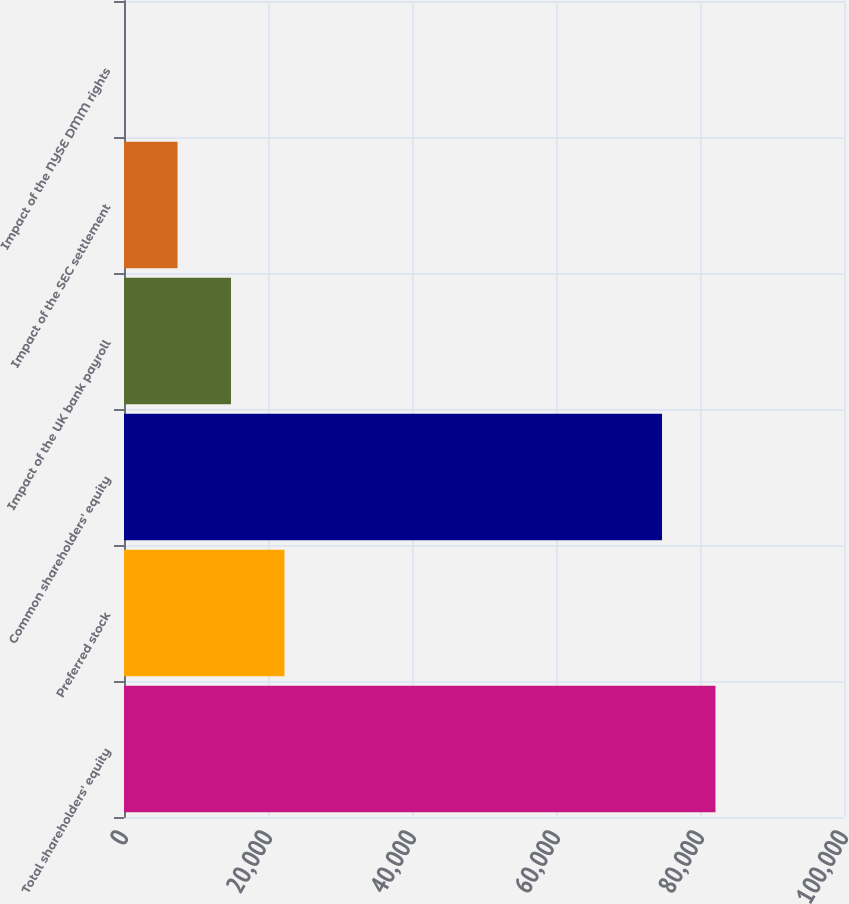Convert chart. <chart><loc_0><loc_0><loc_500><loc_500><bar_chart><fcel>Total shareholders' equity<fcel>Preferred stock<fcel>Common shareholders' equity<fcel>Impact of the UK bank payroll<fcel>Impact of the SEC settlement<fcel>Impact of the NYSE DMM rights<nl><fcel>82148.6<fcel>22286.9<fcel>74724.3<fcel>14862.6<fcel>7438.3<fcel>14<nl></chart> 